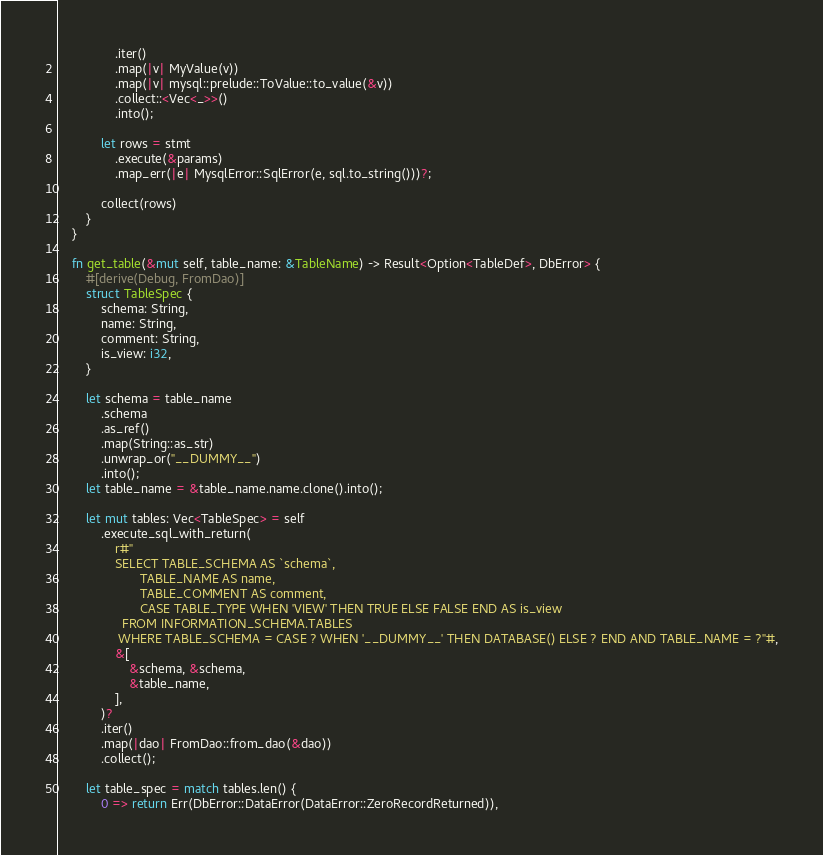Convert code to text. <code><loc_0><loc_0><loc_500><loc_500><_Rust_>                .iter()
                .map(|v| MyValue(v))
                .map(|v| mysql::prelude::ToValue::to_value(&v))
                .collect::<Vec<_>>()
                .into();

            let rows = stmt
                .execute(&params)
                .map_err(|e| MysqlError::SqlError(e, sql.to_string()))?;

            collect(rows)
        }
    }

    fn get_table(&mut self, table_name: &TableName) -> Result<Option<TableDef>, DbError> {
        #[derive(Debug, FromDao)]
        struct TableSpec {
            schema: String,
            name: String,
            comment: String,
            is_view: i32,
        }

        let schema = table_name
            .schema
            .as_ref()
            .map(String::as_str)
            .unwrap_or("__DUMMY__")
            .into();
        let table_name = &table_name.name.clone().into();

        let mut tables: Vec<TableSpec> = self
            .execute_sql_with_return(
                r#"
                SELECT TABLE_SCHEMA AS `schema`,
                       TABLE_NAME AS name,
                       TABLE_COMMENT AS comment,
                       CASE TABLE_TYPE WHEN 'VIEW' THEN TRUE ELSE FALSE END AS is_view
                  FROM INFORMATION_SCHEMA.TABLES
                 WHERE TABLE_SCHEMA = CASE ? WHEN '__DUMMY__' THEN DATABASE() ELSE ? END AND TABLE_NAME = ?"#,
                &[
                    &schema, &schema,
                    &table_name,
                ],
            )?
            .iter()
            .map(|dao| FromDao::from_dao(&dao))
            .collect();

        let table_spec = match tables.len() {
            0 => return Err(DbError::DataError(DataError::ZeroRecordReturned)),</code> 